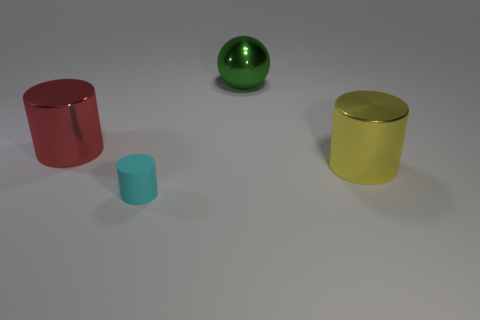How many other things are the same shape as the large yellow thing?
Give a very brief answer. 2. Are there any other things that have the same material as the tiny thing?
Your answer should be compact. No. The object in front of the large shiny cylinder in front of the red metallic object is what shape?
Keep it short and to the point. Cylinder. Do the metal thing to the left of the metal ball and the green metallic object have the same shape?
Offer a very short reply. No. Are there more things left of the green object than red metallic objects that are to the left of the small cylinder?
Offer a very short reply. Yes. What number of green balls are on the left side of the large shiny thing that is on the right side of the large green metal object?
Your answer should be very brief. 1. What number of other objects are there of the same color as the ball?
Give a very brief answer. 0. There is a shiny cylinder that is behind the shiny object in front of the large red shiny thing; what is its color?
Your answer should be compact. Red. How many rubber things are either spheres or large red spheres?
Make the answer very short. 0. Is there a big red cylinder made of the same material as the green object?
Offer a very short reply. Yes. 